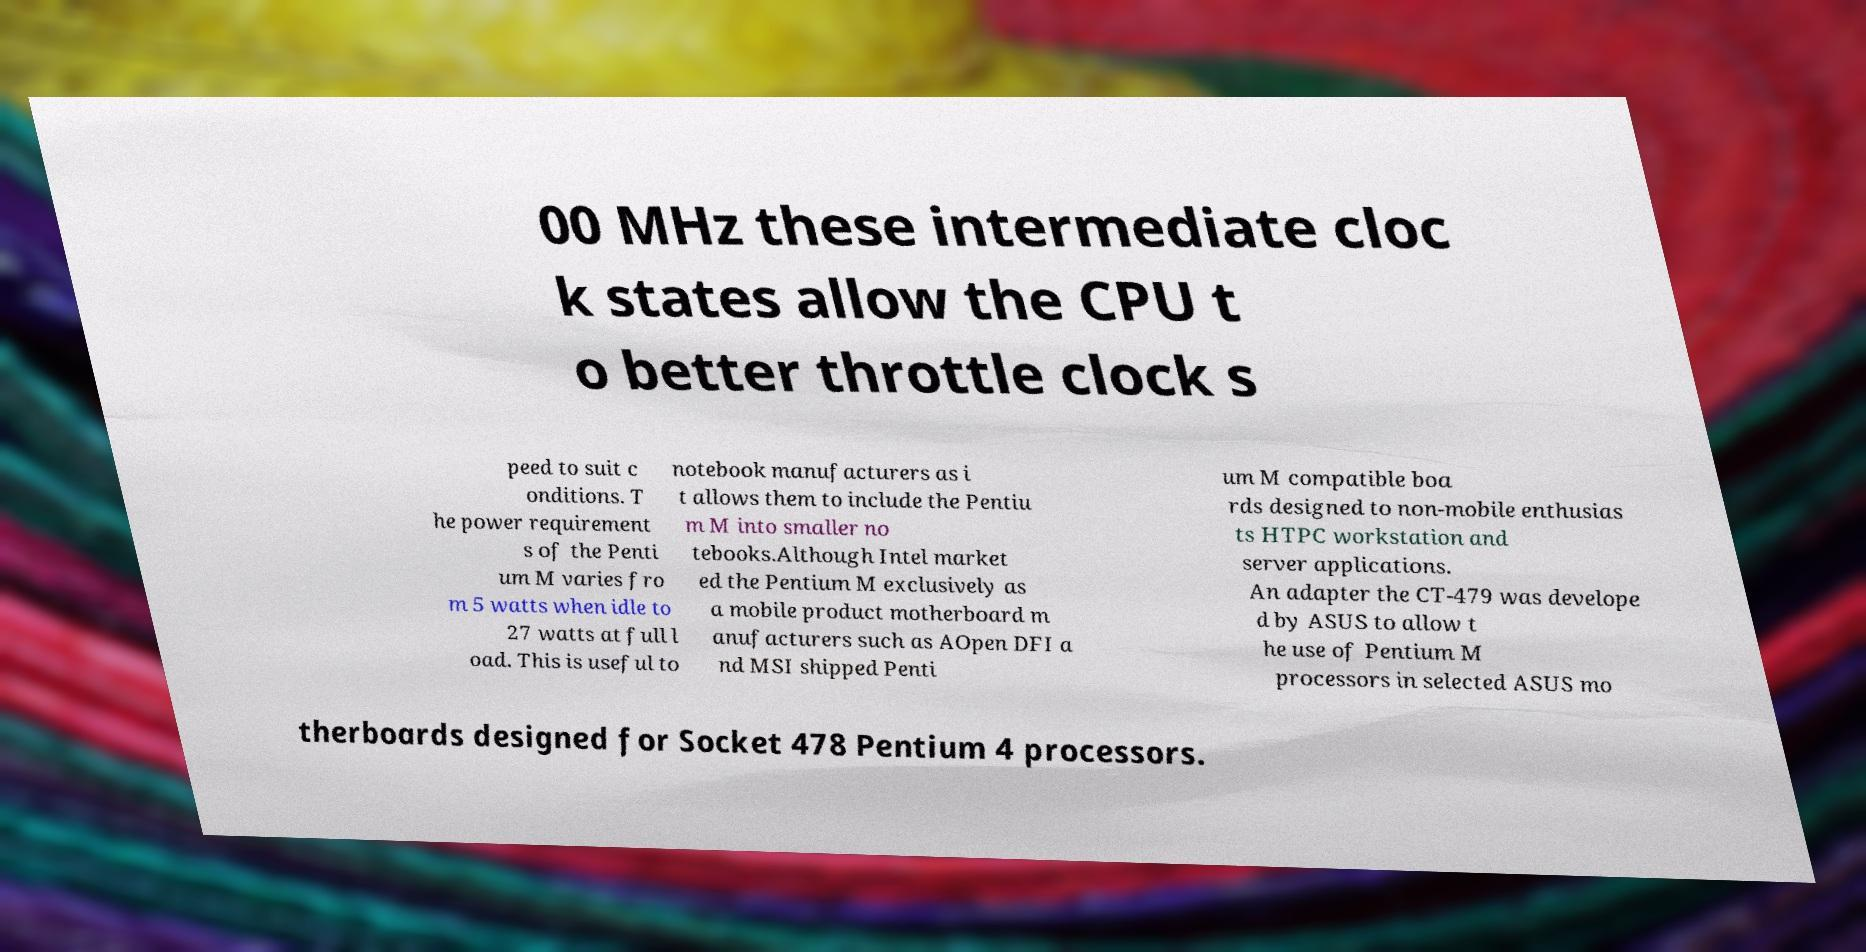Could you extract and type out the text from this image? 00 MHz these intermediate cloc k states allow the CPU t o better throttle clock s peed to suit c onditions. T he power requirement s of the Penti um M varies fro m 5 watts when idle to 27 watts at full l oad. This is useful to notebook manufacturers as i t allows them to include the Pentiu m M into smaller no tebooks.Although Intel market ed the Pentium M exclusively as a mobile product motherboard m anufacturers such as AOpen DFI a nd MSI shipped Penti um M compatible boa rds designed to non-mobile enthusias ts HTPC workstation and server applications. An adapter the CT-479 was develope d by ASUS to allow t he use of Pentium M processors in selected ASUS mo therboards designed for Socket 478 Pentium 4 processors. 